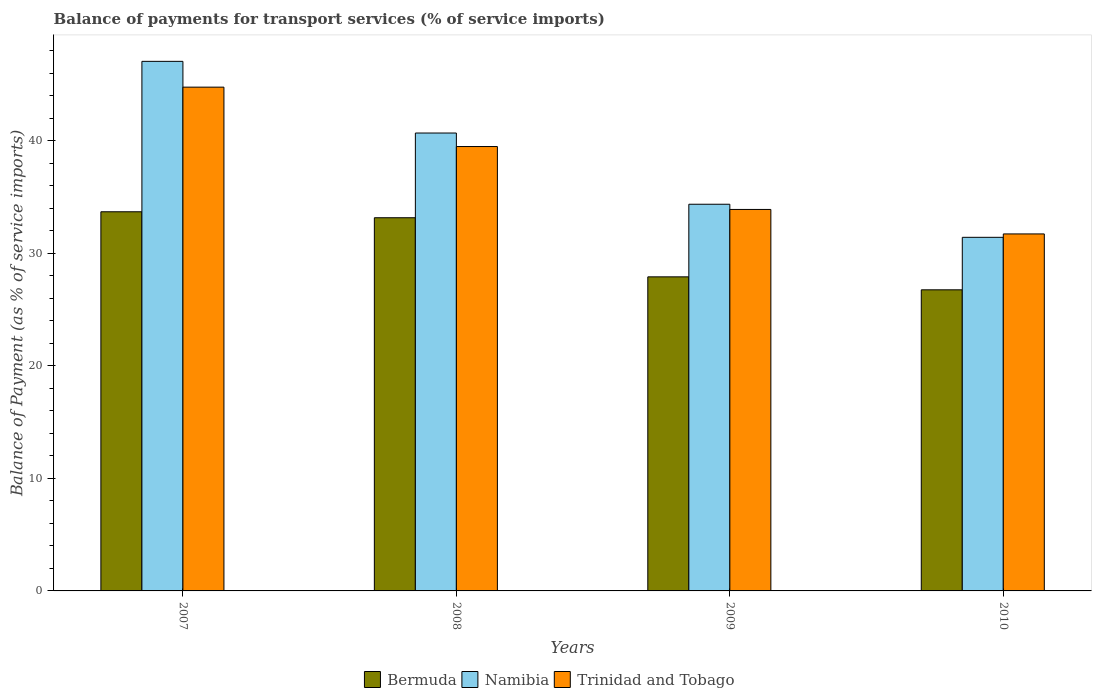Are the number of bars per tick equal to the number of legend labels?
Offer a very short reply. Yes. Are the number of bars on each tick of the X-axis equal?
Offer a very short reply. Yes. What is the label of the 2nd group of bars from the left?
Make the answer very short. 2008. What is the balance of payments for transport services in Bermuda in 2009?
Provide a succinct answer. 27.9. Across all years, what is the maximum balance of payments for transport services in Trinidad and Tobago?
Your answer should be compact. 44.75. Across all years, what is the minimum balance of payments for transport services in Bermuda?
Your response must be concise. 26.75. What is the total balance of payments for transport services in Bermuda in the graph?
Make the answer very short. 121.49. What is the difference between the balance of payments for transport services in Trinidad and Tobago in 2007 and that in 2008?
Give a very brief answer. 5.28. What is the difference between the balance of payments for transport services in Bermuda in 2007 and the balance of payments for transport services in Trinidad and Tobago in 2010?
Your answer should be very brief. 1.97. What is the average balance of payments for transport services in Trinidad and Tobago per year?
Your answer should be compact. 37.46. In the year 2010, what is the difference between the balance of payments for transport services in Trinidad and Tobago and balance of payments for transport services in Namibia?
Provide a short and direct response. 0.3. What is the ratio of the balance of payments for transport services in Namibia in 2007 to that in 2008?
Provide a succinct answer. 1.16. What is the difference between the highest and the second highest balance of payments for transport services in Trinidad and Tobago?
Make the answer very short. 5.28. What is the difference between the highest and the lowest balance of payments for transport services in Bermuda?
Your response must be concise. 6.93. What does the 3rd bar from the left in 2009 represents?
Offer a terse response. Trinidad and Tobago. What does the 3rd bar from the right in 2010 represents?
Offer a terse response. Bermuda. Is it the case that in every year, the sum of the balance of payments for transport services in Trinidad and Tobago and balance of payments for transport services in Namibia is greater than the balance of payments for transport services in Bermuda?
Make the answer very short. Yes. Are all the bars in the graph horizontal?
Offer a terse response. No. Are the values on the major ticks of Y-axis written in scientific E-notation?
Keep it short and to the point. No. Does the graph contain any zero values?
Offer a very short reply. No. What is the title of the graph?
Keep it short and to the point. Balance of payments for transport services (% of service imports). Does "Indonesia" appear as one of the legend labels in the graph?
Provide a succinct answer. No. What is the label or title of the X-axis?
Your answer should be very brief. Years. What is the label or title of the Y-axis?
Give a very brief answer. Balance of Payment (as % of service imports). What is the Balance of Payment (as % of service imports) of Bermuda in 2007?
Your answer should be very brief. 33.68. What is the Balance of Payment (as % of service imports) in Namibia in 2007?
Provide a short and direct response. 47.05. What is the Balance of Payment (as % of service imports) of Trinidad and Tobago in 2007?
Make the answer very short. 44.75. What is the Balance of Payment (as % of service imports) in Bermuda in 2008?
Provide a succinct answer. 33.15. What is the Balance of Payment (as % of service imports) of Namibia in 2008?
Your answer should be compact. 40.68. What is the Balance of Payment (as % of service imports) of Trinidad and Tobago in 2008?
Make the answer very short. 39.48. What is the Balance of Payment (as % of service imports) in Bermuda in 2009?
Ensure brevity in your answer.  27.9. What is the Balance of Payment (as % of service imports) in Namibia in 2009?
Your response must be concise. 34.35. What is the Balance of Payment (as % of service imports) of Trinidad and Tobago in 2009?
Provide a short and direct response. 33.89. What is the Balance of Payment (as % of service imports) of Bermuda in 2010?
Provide a short and direct response. 26.75. What is the Balance of Payment (as % of service imports) of Namibia in 2010?
Your response must be concise. 31.41. What is the Balance of Payment (as % of service imports) of Trinidad and Tobago in 2010?
Keep it short and to the point. 31.71. Across all years, what is the maximum Balance of Payment (as % of service imports) of Bermuda?
Keep it short and to the point. 33.68. Across all years, what is the maximum Balance of Payment (as % of service imports) of Namibia?
Your answer should be compact. 47.05. Across all years, what is the maximum Balance of Payment (as % of service imports) of Trinidad and Tobago?
Give a very brief answer. 44.75. Across all years, what is the minimum Balance of Payment (as % of service imports) of Bermuda?
Keep it short and to the point. 26.75. Across all years, what is the minimum Balance of Payment (as % of service imports) in Namibia?
Your answer should be compact. 31.41. Across all years, what is the minimum Balance of Payment (as % of service imports) of Trinidad and Tobago?
Make the answer very short. 31.71. What is the total Balance of Payment (as % of service imports) in Bermuda in the graph?
Provide a short and direct response. 121.49. What is the total Balance of Payment (as % of service imports) in Namibia in the graph?
Give a very brief answer. 153.49. What is the total Balance of Payment (as % of service imports) in Trinidad and Tobago in the graph?
Make the answer very short. 149.84. What is the difference between the Balance of Payment (as % of service imports) of Bermuda in 2007 and that in 2008?
Your answer should be compact. 0.53. What is the difference between the Balance of Payment (as % of service imports) in Namibia in 2007 and that in 2008?
Offer a terse response. 6.37. What is the difference between the Balance of Payment (as % of service imports) in Trinidad and Tobago in 2007 and that in 2008?
Your response must be concise. 5.28. What is the difference between the Balance of Payment (as % of service imports) of Bermuda in 2007 and that in 2009?
Offer a very short reply. 5.78. What is the difference between the Balance of Payment (as % of service imports) in Namibia in 2007 and that in 2009?
Ensure brevity in your answer.  12.69. What is the difference between the Balance of Payment (as % of service imports) in Trinidad and Tobago in 2007 and that in 2009?
Your answer should be very brief. 10.86. What is the difference between the Balance of Payment (as % of service imports) of Bermuda in 2007 and that in 2010?
Your answer should be compact. 6.93. What is the difference between the Balance of Payment (as % of service imports) of Namibia in 2007 and that in 2010?
Your answer should be very brief. 15.63. What is the difference between the Balance of Payment (as % of service imports) of Trinidad and Tobago in 2007 and that in 2010?
Provide a short and direct response. 13.04. What is the difference between the Balance of Payment (as % of service imports) of Bermuda in 2008 and that in 2009?
Provide a succinct answer. 5.25. What is the difference between the Balance of Payment (as % of service imports) of Namibia in 2008 and that in 2009?
Offer a terse response. 6.33. What is the difference between the Balance of Payment (as % of service imports) in Trinidad and Tobago in 2008 and that in 2009?
Your answer should be compact. 5.59. What is the difference between the Balance of Payment (as % of service imports) of Bermuda in 2008 and that in 2010?
Keep it short and to the point. 6.4. What is the difference between the Balance of Payment (as % of service imports) in Namibia in 2008 and that in 2010?
Give a very brief answer. 9.27. What is the difference between the Balance of Payment (as % of service imports) in Trinidad and Tobago in 2008 and that in 2010?
Make the answer very short. 7.76. What is the difference between the Balance of Payment (as % of service imports) of Bermuda in 2009 and that in 2010?
Provide a succinct answer. 1.15. What is the difference between the Balance of Payment (as % of service imports) of Namibia in 2009 and that in 2010?
Your answer should be very brief. 2.94. What is the difference between the Balance of Payment (as % of service imports) in Trinidad and Tobago in 2009 and that in 2010?
Your answer should be very brief. 2.18. What is the difference between the Balance of Payment (as % of service imports) of Bermuda in 2007 and the Balance of Payment (as % of service imports) of Namibia in 2008?
Provide a short and direct response. -7. What is the difference between the Balance of Payment (as % of service imports) of Bermuda in 2007 and the Balance of Payment (as % of service imports) of Trinidad and Tobago in 2008?
Provide a short and direct response. -5.8. What is the difference between the Balance of Payment (as % of service imports) of Namibia in 2007 and the Balance of Payment (as % of service imports) of Trinidad and Tobago in 2008?
Make the answer very short. 7.57. What is the difference between the Balance of Payment (as % of service imports) in Bermuda in 2007 and the Balance of Payment (as % of service imports) in Namibia in 2009?
Ensure brevity in your answer.  -0.67. What is the difference between the Balance of Payment (as % of service imports) in Bermuda in 2007 and the Balance of Payment (as % of service imports) in Trinidad and Tobago in 2009?
Your answer should be very brief. -0.21. What is the difference between the Balance of Payment (as % of service imports) of Namibia in 2007 and the Balance of Payment (as % of service imports) of Trinidad and Tobago in 2009?
Your response must be concise. 13.16. What is the difference between the Balance of Payment (as % of service imports) of Bermuda in 2007 and the Balance of Payment (as % of service imports) of Namibia in 2010?
Your response must be concise. 2.27. What is the difference between the Balance of Payment (as % of service imports) of Bermuda in 2007 and the Balance of Payment (as % of service imports) of Trinidad and Tobago in 2010?
Provide a short and direct response. 1.97. What is the difference between the Balance of Payment (as % of service imports) of Namibia in 2007 and the Balance of Payment (as % of service imports) of Trinidad and Tobago in 2010?
Keep it short and to the point. 15.33. What is the difference between the Balance of Payment (as % of service imports) in Bermuda in 2008 and the Balance of Payment (as % of service imports) in Namibia in 2009?
Provide a short and direct response. -1.2. What is the difference between the Balance of Payment (as % of service imports) of Bermuda in 2008 and the Balance of Payment (as % of service imports) of Trinidad and Tobago in 2009?
Keep it short and to the point. -0.74. What is the difference between the Balance of Payment (as % of service imports) in Namibia in 2008 and the Balance of Payment (as % of service imports) in Trinidad and Tobago in 2009?
Offer a terse response. 6.79. What is the difference between the Balance of Payment (as % of service imports) of Bermuda in 2008 and the Balance of Payment (as % of service imports) of Namibia in 2010?
Offer a very short reply. 1.74. What is the difference between the Balance of Payment (as % of service imports) in Bermuda in 2008 and the Balance of Payment (as % of service imports) in Trinidad and Tobago in 2010?
Your answer should be compact. 1.44. What is the difference between the Balance of Payment (as % of service imports) in Namibia in 2008 and the Balance of Payment (as % of service imports) in Trinidad and Tobago in 2010?
Provide a short and direct response. 8.96. What is the difference between the Balance of Payment (as % of service imports) of Bermuda in 2009 and the Balance of Payment (as % of service imports) of Namibia in 2010?
Your answer should be compact. -3.51. What is the difference between the Balance of Payment (as % of service imports) in Bermuda in 2009 and the Balance of Payment (as % of service imports) in Trinidad and Tobago in 2010?
Your answer should be very brief. -3.81. What is the difference between the Balance of Payment (as % of service imports) of Namibia in 2009 and the Balance of Payment (as % of service imports) of Trinidad and Tobago in 2010?
Your answer should be very brief. 2.64. What is the average Balance of Payment (as % of service imports) in Bermuda per year?
Offer a very short reply. 30.37. What is the average Balance of Payment (as % of service imports) in Namibia per year?
Offer a very short reply. 38.37. What is the average Balance of Payment (as % of service imports) of Trinidad and Tobago per year?
Give a very brief answer. 37.46. In the year 2007, what is the difference between the Balance of Payment (as % of service imports) in Bermuda and Balance of Payment (as % of service imports) in Namibia?
Provide a succinct answer. -13.36. In the year 2007, what is the difference between the Balance of Payment (as % of service imports) in Bermuda and Balance of Payment (as % of service imports) in Trinidad and Tobago?
Give a very brief answer. -11.07. In the year 2007, what is the difference between the Balance of Payment (as % of service imports) in Namibia and Balance of Payment (as % of service imports) in Trinidad and Tobago?
Your answer should be compact. 2.29. In the year 2008, what is the difference between the Balance of Payment (as % of service imports) of Bermuda and Balance of Payment (as % of service imports) of Namibia?
Provide a short and direct response. -7.53. In the year 2008, what is the difference between the Balance of Payment (as % of service imports) of Bermuda and Balance of Payment (as % of service imports) of Trinidad and Tobago?
Give a very brief answer. -6.33. In the year 2008, what is the difference between the Balance of Payment (as % of service imports) in Namibia and Balance of Payment (as % of service imports) in Trinidad and Tobago?
Give a very brief answer. 1.2. In the year 2009, what is the difference between the Balance of Payment (as % of service imports) of Bermuda and Balance of Payment (as % of service imports) of Namibia?
Ensure brevity in your answer.  -6.45. In the year 2009, what is the difference between the Balance of Payment (as % of service imports) of Bermuda and Balance of Payment (as % of service imports) of Trinidad and Tobago?
Keep it short and to the point. -5.99. In the year 2009, what is the difference between the Balance of Payment (as % of service imports) of Namibia and Balance of Payment (as % of service imports) of Trinidad and Tobago?
Keep it short and to the point. 0.46. In the year 2010, what is the difference between the Balance of Payment (as % of service imports) of Bermuda and Balance of Payment (as % of service imports) of Namibia?
Keep it short and to the point. -4.66. In the year 2010, what is the difference between the Balance of Payment (as % of service imports) of Bermuda and Balance of Payment (as % of service imports) of Trinidad and Tobago?
Ensure brevity in your answer.  -4.97. In the year 2010, what is the difference between the Balance of Payment (as % of service imports) in Namibia and Balance of Payment (as % of service imports) in Trinidad and Tobago?
Provide a succinct answer. -0.3. What is the ratio of the Balance of Payment (as % of service imports) in Bermuda in 2007 to that in 2008?
Provide a succinct answer. 1.02. What is the ratio of the Balance of Payment (as % of service imports) in Namibia in 2007 to that in 2008?
Ensure brevity in your answer.  1.16. What is the ratio of the Balance of Payment (as % of service imports) of Trinidad and Tobago in 2007 to that in 2008?
Make the answer very short. 1.13. What is the ratio of the Balance of Payment (as % of service imports) in Bermuda in 2007 to that in 2009?
Your response must be concise. 1.21. What is the ratio of the Balance of Payment (as % of service imports) in Namibia in 2007 to that in 2009?
Ensure brevity in your answer.  1.37. What is the ratio of the Balance of Payment (as % of service imports) of Trinidad and Tobago in 2007 to that in 2009?
Ensure brevity in your answer.  1.32. What is the ratio of the Balance of Payment (as % of service imports) in Bermuda in 2007 to that in 2010?
Provide a short and direct response. 1.26. What is the ratio of the Balance of Payment (as % of service imports) in Namibia in 2007 to that in 2010?
Ensure brevity in your answer.  1.5. What is the ratio of the Balance of Payment (as % of service imports) of Trinidad and Tobago in 2007 to that in 2010?
Give a very brief answer. 1.41. What is the ratio of the Balance of Payment (as % of service imports) of Bermuda in 2008 to that in 2009?
Offer a terse response. 1.19. What is the ratio of the Balance of Payment (as % of service imports) of Namibia in 2008 to that in 2009?
Provide a short and direct response. 1.18. What is the ratio of the Balance of Payment (as % of service imports) in Trinidad and Tobago in 2008 to that in 2009?
Keep it short and to the point. 1.16. What is the ratio of the Balance of Payment (as % of service imports) in Bermuda in 2008 to that in 2010?
Offer a very short reply. 1.24. What is the ratio of the Balance of Payment (as % of service imports) of Namibia in 2008 to that in 2010?
Your answer should be compact. 1.29. What is the ratio of the Balance of Payment (as % of service imports) of Trinidad and Tobago in 2008 to that in 2010?
Make the answer very short. 1.24. What is the ratio of the Balance of Payment (as % of service imports) of Bermuda in 2009 to that in 2010?
Your response must be concise. 1.04. What is the ratio of the Balance of Payment (as % of service imports) in Namibia in 2009 to that in 2010?
Your answer should be compact. 1.09. What is the ratio of the Balance of Payment (as % of service imports) of Trinidad and Tobago in 2009 to that in 2010?
Give a very brief answer. 1.07. What is the difference between the highest and the second highest Balance of Payment (as % of service imports) in Bermuda?
Provide a succinct answer. 0.53. What is the difference between the highest and the second highest Balance of Payment (as % of service imports) in Namibia?
Provide a short and direct response. 6.37. What is the difference between the highest and the second highest Balance of Payment (as % of service imports) of Trinidad and Tobago?
Ensure brevity in your answer.  5.28. What is the difference between the highest and the lowest Balance of Payment (as % of service imports) in Bermuda?
Provide a short and direct response. 6.93. What is the difference between the highest and the lowest Balance of Payment (as % of service imports) in Namibia?
Give a very brief answer. 15.63. What is the difference between the highest and the lowest Balance of Payment (as % of service imports) in Trinidad and Tobago?
Your answer should be compact. 13.04. 